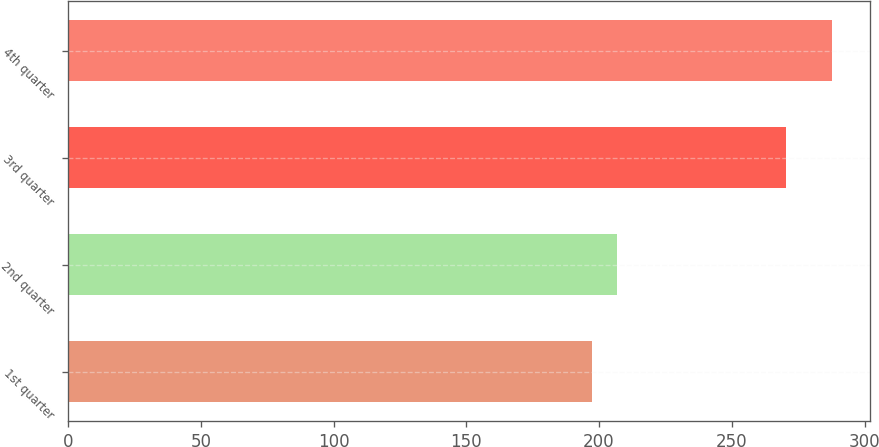Convert chart. <chart><loc_0><loc_0><loc_500><loc_500><bar_chart><fcel>1st quarter<fcel>2nd quarter<fcel>3rd quarter<fcel>4th quarter<nl><fcel>197.5<fcel>206.8<fcel>270.3<fcel>287.7<nl></chart> 